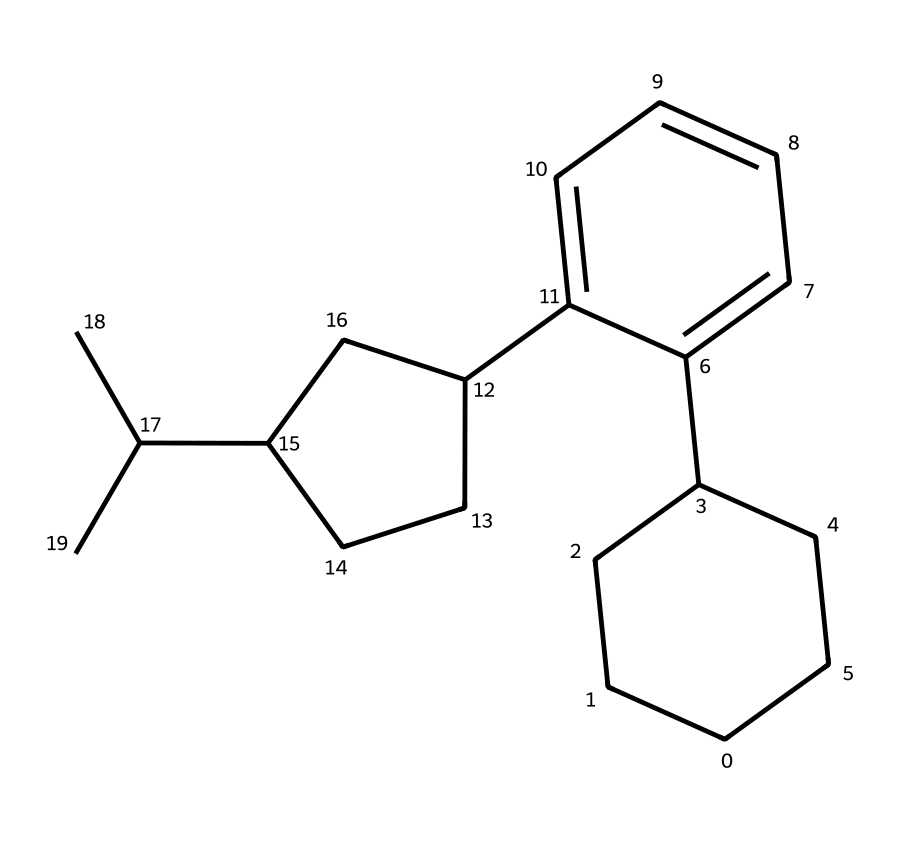What is the molecular formula of the compound? To determine the molecular formula, we need to identify the number of each type of atom present in the chemical structure. By analyzing the SMILES representation, we can see there are 15 carbon atoms and 24 hydrogen atoms. Therefore, the molecular formula is C15H24.
Answer: C15H24 How many rings are present in the structure? In the provided SMILES, we can identify ring structures by looking for the numbers that indicate where the atoms connect to form rings. Here, we see there are three distinct rings due to the numbers 1, 2, and 3 appearing in pairs. Thus, there are 3 rings.
Answer: 3 What is the significance of the double bonds in the structure? The presence of double bonds in the chemical structure contributes to the unsaturation of the compound, influencing its reactivity and stability. In this chemical, two carbon-carbon double bonds indicate potential sites for reactions and are important for its therapeutic activities.
Answer: unsaturation Is this compound classified as a terpene? By analyzing the structure, especially noting the branched hydrocarbon framework and the presence of isoprene units, it can be concluded that this compound fits the classification of terpenes, which are derived from isoprene.
Answer: yes What role do terpenoids serve in Pandanus? Terpenoids in Pandanus serve various roles including defense against herbivores, attraction of pollinators, and contributing to the plant's aroma. Analyzing the chemical structure helps to understand its biological functions.
Answer: defense and attraction 